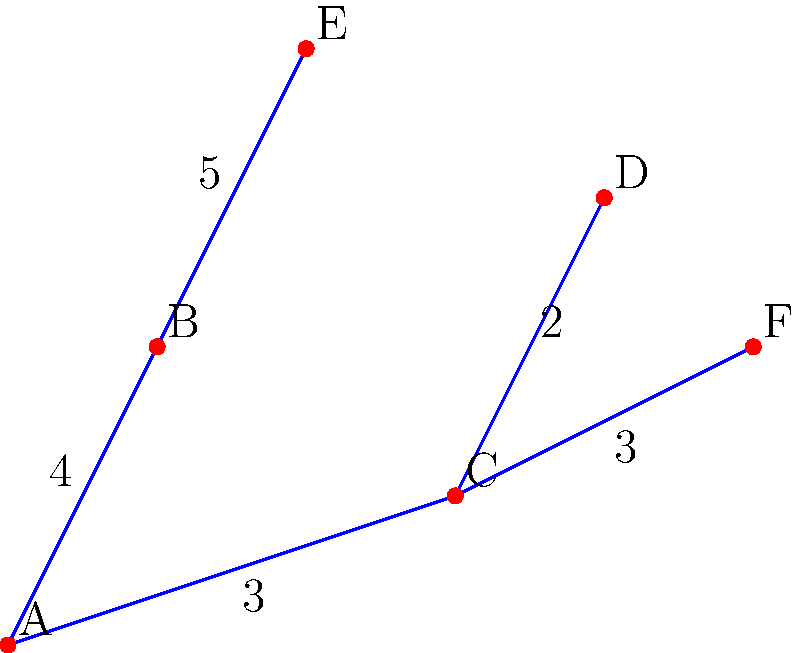Given the graph representing potential locations for emergency services in a city, where each vertex represents a neighborhood and the edges represent roads connecting them with associated costs (in millions of dollars) for infrastructure upgrades, what is the minimum total cost to ensure all neighborhoods are connected while minimizing expenses? How might this approach impact the ethical distribution of emergency services across the city? To find the minimum total cost to connect all neighborhoods while minimizing expenses, we need to find the Minimum Spanning Tree (MST) of the given graph. We can use Kruskal's algorithm to find the MST:

1. Sort all edges by weight in ascending order:
   (C,D): 2
   (A,C): 3
   (C,F): 3
   (A,B): 4
   (B,E): 5

2. Start with an empty set and add edges that don't create cycles:
   - Add (C,D): 2
   - Add (A,C): 3
   - Add (C,F): 3
   - Add (A,B): 4

3. The MST is now complete, connecting all vertices.

4. Calculate the total cost: 2 + 3 + 3 + 4 = 12 million dollars

Ethical considerations:
1. This approach prioritizes cost-efficiency over equal distribution of services.
2. Neighborhoods B and E are at the "ends" of the tree, potentially leading to longer response times.
3. The central location C might be overburdened as it connects to multiple areas.
4. This model doesn't account for population density or specific emergency service needs of each neighborhood.
5. It assumes all roads are equally viable for emergency vehicle transit, which may not be true in reality.
Answer: $12 million; potential ethical issues include unequal service distribution and response times. 